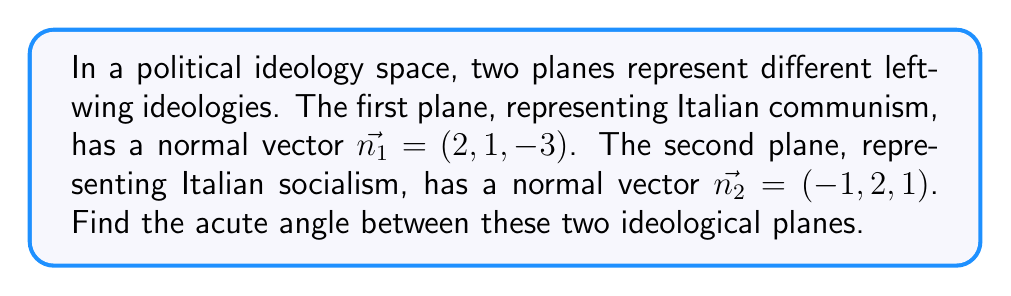Teach me how to tackle this problem. To find the angle between two planes, we need to calculate the angle between their normal vectors. We can use the dot product formula:

$$\cos \theta = \frac{\vec{n_1} \cdot \vec{n_2}}{|\vec{n_1}| |\vec{n_2}|}$$

Where $\theta$ is the angle between the planes, $\vec{n_1}$ and $\vec{n_2}$ are the normal vectors, and $|\vec{n_1}|$ and $|\vec{n_2}|$ are their magnitudes.

Step 1: Calculate the dot product $\vec{n_1} \cdot \vec{n_2}$
$$\vec{n_1} \cdot \vec{n_2} = (2)(-1) + (1)(2) + (-3)(1) = -2 + 2 - 3 = -3$$

Step 2: Calculate the magnitudes of the vectors
$$|\vec{n_1}| = \sqrt{2^2 + 1^2 + (-3)^2} = \sqrt{4 + 1 + 9} = \sqrt{14}$$
$$|\vec{n_2}| = \sqrt{(-1)^2 + 2^2 + 1^2} = \sqrt{1 + 4 + 1} = \sqrt{6}$$

Step 3: Substitute into the cosine formula
$$\cos \theta = \frac{-3}{\sqrt{14} \sqrt{6}}$$

Step 4: Take the inverse cosine (arccos) of both sides
$$\theta = \arccos\left(\frac{-3}{\sqrt{14} \sqrt{6}}\right)$$

Step 5: Calculate the result (rounded to two decimal places)
$$\theta \approx 2.00 \text{ radians} \approx 114.59°$$
Answer: The acute angle between the two ideological planes is approximately 65.41° (the complement of 114.59°). 